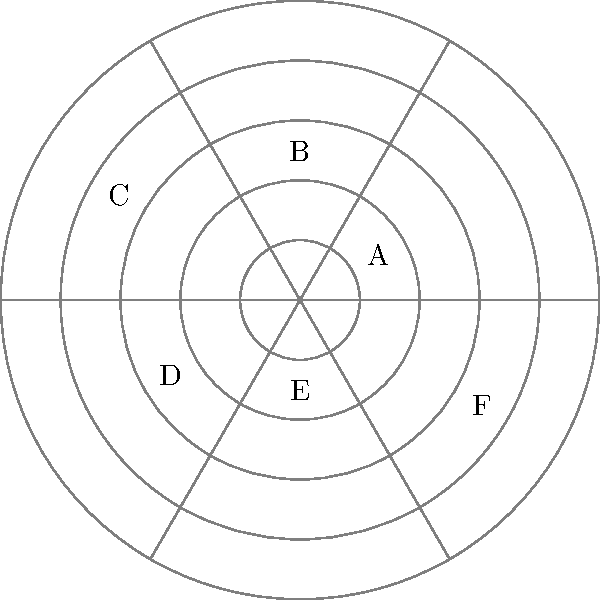As a product designer, you've segmented your market into six distinct sectors (A-F) based on customer preferences and buying behaviors. The polar coordinate diagram represents these segments, where the angle denotes the market sector and the radius indicates the segment's relative size. Which two market segments should you prioritize for product development and marketing efforts to maximize potential revenue, assuming all other factors are equal? To determine which two market segments to prioritize, we need to analyze the relative sizes of each segment as represented by their radii in the polar coordinate diagram. Here's the step-by-step process:

1. Observe the six market segments labeled A through F.
2. Compare the radii of each segment:
   - Segment A: relatively small (radius ≈ 1.5)
   - Segment B: medium-sized (radius ≈ 2.5)
   - Segment C: large (radius ≈ 3.5)
   - Segment D: medium-sized (radius ≈ 2.5)
   - Segment E: relatively small (radius ≈ 1.5)
   - Segment F: large (radius ≈ 3.5)

3. Identify the segments with the largest radii, which represent the largest market segments.
4. The two largest segments are C and F, both with a radius of approximately 3.5.

By focusing on these two largest segments, you can potentially reach the greatest number of customers and maximize revenue, assuming all other factors (such as profitability per customer, ease of access, etc.) are equal across all segments.
Answer: Segments C and F 